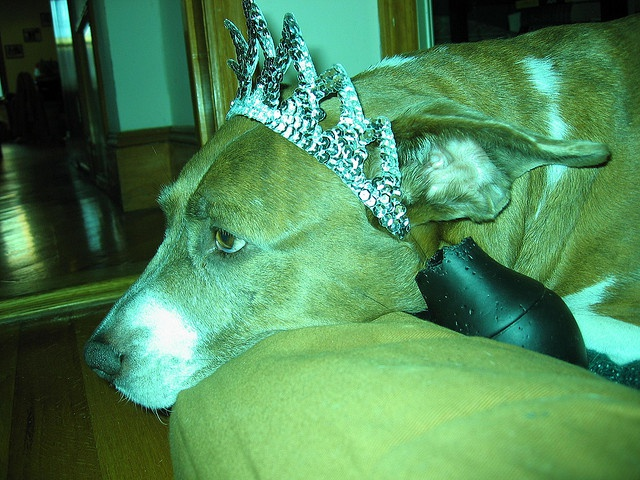Describe the objects in this image and their specific colors. I can see dog in black, green, darkgreen, aquamarine, and lightgreen tones and couch in black and lightgreen tones in this image. 